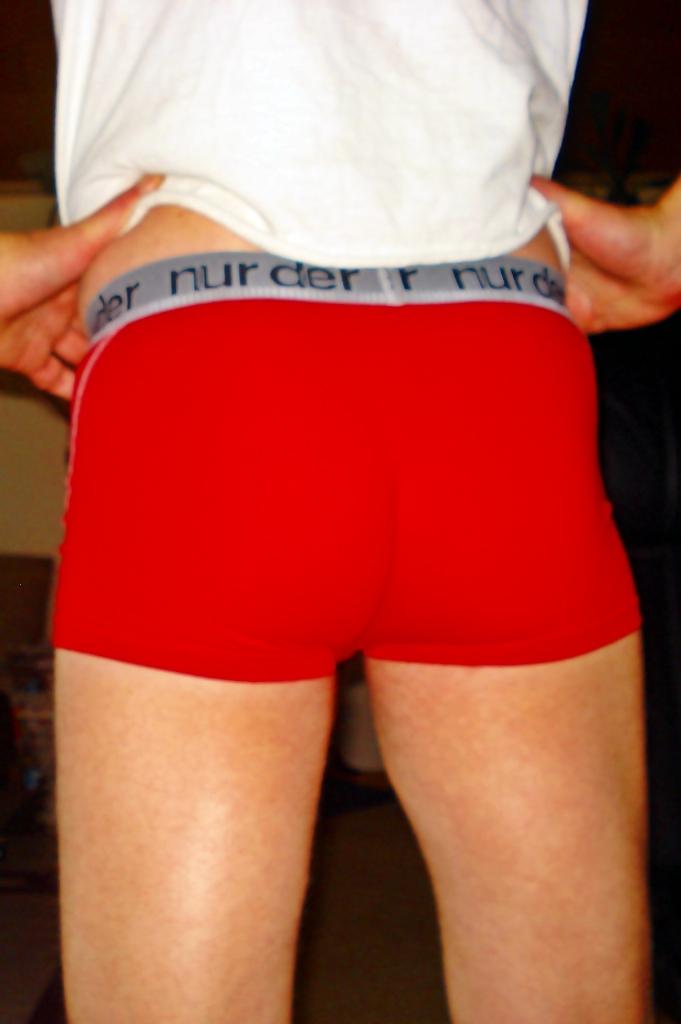Who made the underwear?
Make the answer very short. Nurder. What brand of underwear is this?
Make the answer very short. Nurder. 